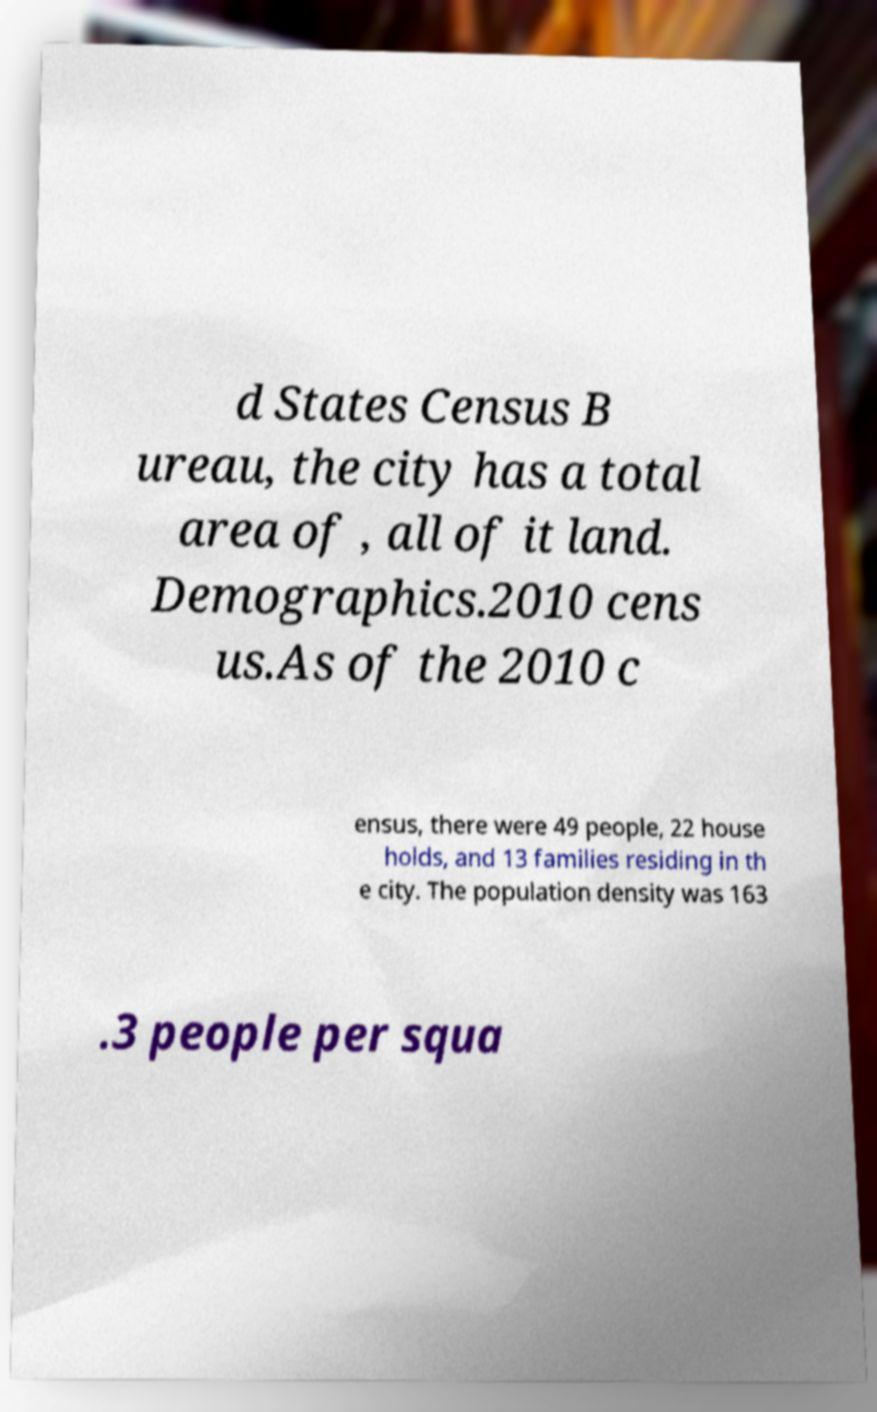Please read and relay the text visible in this image. What does it say? d States Census B ureau, the city has a total area of , all of it land. Demographics.2010 cens us.As of the 2010 c ensus, there were 49 people, 22 house holds, and 13 families residing in th e city. The population density was 163 .3 people per squa 